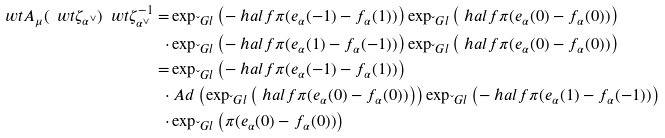<formula> <loc_0><loc_0><loc_500><loc_500>\ w t A _ { \mu } ( \ w t \zeta _ { \alpha ^ { \vee } } ) \ w t \zeta _ { \alpha ^ { \vee } } ^ { - 1 } = & \exp _ { \L G l } \left ( - \ h a l f { \pi } ( e _ { \alpha } ( - 1 ) - f _ { \alpha } ( 1 ) ) \right ) \exp _ { \L G l } \left ( \ h a l f { \pi } ( e _ { \alpha } ( 0 ) - f _ { \alpha } ( 0 ) ) \right ) \\ \cdot & \exp _ { \L G l } \left ( - \ h a l f { \pi } ( e _ { \alpha } ( 1 ) - f _ { \alpha } ( - 1 ) ) \right ) \exp _ { \L G l } \left ( \ h a l f { \pi } ( e _ { \alpha } ( 0 ) - f _ { \alpha } ( 0 ) ) \right ) \\ = & \exp _ { \L G l } \left ( - \ h a l f { \pi } ( e _ { \alpha } ( - 1 ) - f _ { \alpha } ( 1 ) ) \right ) \\ \cdot & \ A d \left ( \exp _ { \L G l } \left ( \ h a l f { \pi } ( e _ { \alpha } ( 0 ) - f _ { \alpha } ( 0 ) ) \right ) \right ) \exp _ { \L G l } \left ( - \ h a l f { \pi } ( e _ { \alpha } ( 1 ) - f _ { \alpha } ( - 1 ) ) \right ) \\ \cdot & \exp _ { \L G l } \left ( \pi ( e _ { \alpha } ( 0 ) - f _ { \alpha } ( 0 ) ) \right )</formula> 